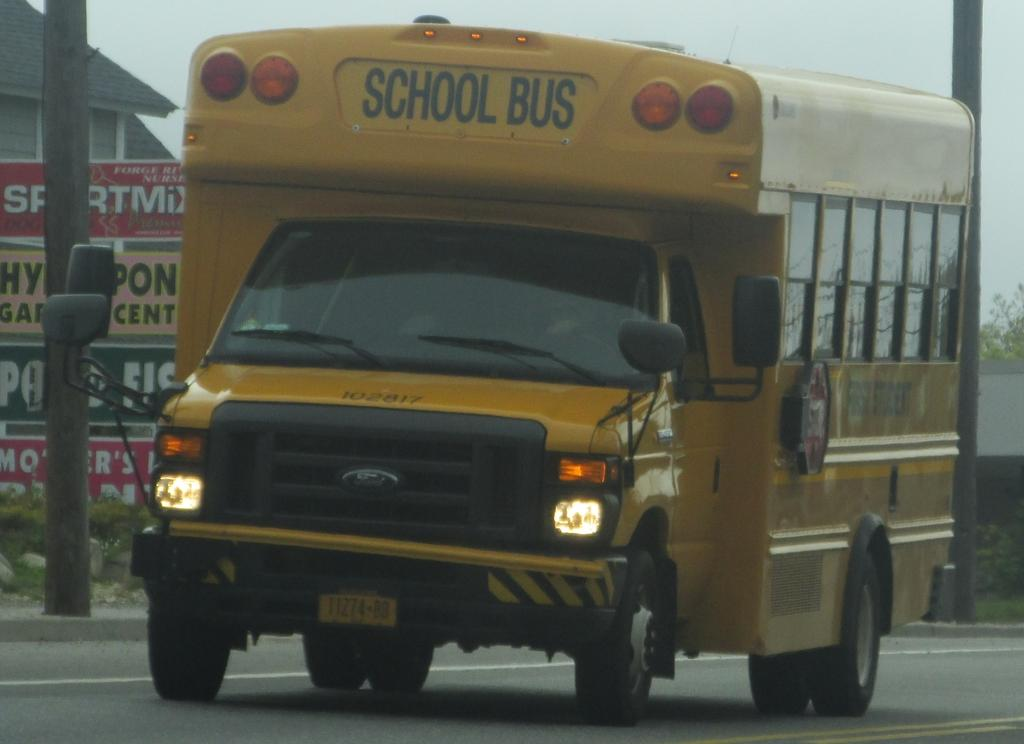What type of vehicle is on the road in the image? There is a motor vehicle on the road in the image. What can be seen in the background of the image? There is an advertisement board, poles, at least one building, plants, and the sky visible in the background. How many elements can be identified in the background of the image? There are five elements present in the background: an advertisement board, poles, a building, plants, and the sky. What type of business is being conducted in the cellar of the building in the image? There is no mention of a cellar or any business activity in the image; it only shows a motor vehicle on the road and various elements in the background. 